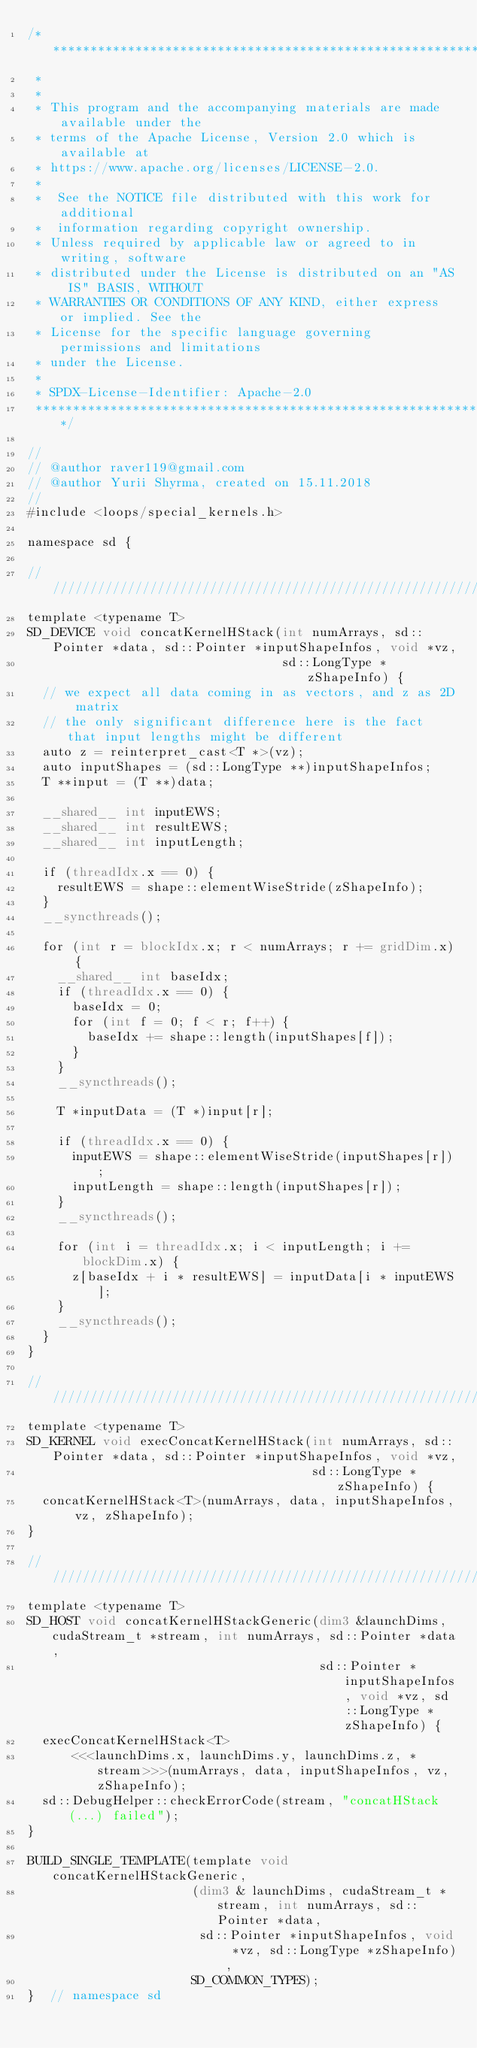<code> <loc_0><loc_0><loc_500><loc_500><_Cuda_>/* ******************************************************************************
 *
 *
 * This program and the accompanying materials are made available under the
 * terms of the Apache License, Version 2.0 which is available at
 * https://www.apache.org/licenses/LICENSE-2.0.
 *
 *  See the NOTICE file distributed with this work for additional
 *  information regarding copyright ownership.
 * Unless required by applicable law or agreed to in writing, software
 * distributed under the License is distributed on an "AS IS" BASIS, WITHOUT
 * WARRANTIES OR CONDITIONS OF ANY KIND, either express or implied. See the
 * License for the specific language governing permissions and limitations
 * under the License.
 *
 * SPDX-License-Identifier: Apache-2.0
 ******************************************************************************/

//
// @author raver119@gmail.com
// @author Yurii Shyrma, created on 15.11.2018
//
#include <loops/special_kernels.h>

namespace sd {

///////////////////////////////////////////////////////////////////////
template <typename T>
SD_DEVICE void concatKernelHStack(int numArrays, sd::Pointer *data, sd::Pointer *inputShapeInfos, void *vz,
                                  sd::LongType *zShapeInfo) {
  // we expect all data coming in as vectors, and z as 2D matrix
  // the only significant difference here is the fact that input lengths might be different
  auto z = reinterpret_cast<T *>(vz);
  auto inputShapes = (sd::LongType **)inputShapeInfos;
  T **input = (T **)data;

  __shared__ int inputEWS;
  __shared__ int resultEWS;
  __shared__ int inputLength;

  if (threadIdx.x == 0) {
    resultEWS = shape::elementWiseStride(zShapeInfo);
  }
  __syncthreads();

  for (int r = blockIdx.x; r < numArrays; r += gridDim.x) {
    __shared__ int baseIdx;
    if (threadIdx.x == 0) {
      baseIdx = 0;
      for (int f = 0; f < r; f++) {
        baseIdx += shape::length(inputShapes[f]);
      }
    }
    __syncthreads();

    T *inputData = (T *)input[r];

    if (threadIdx.x == 0) {
      inputEWS = shape::elementWiseStride(inputShapes[r]);
      inputLength = shape::length(inputShapes[r]);
    }
    __syncthreads();

    for (int i = threadIdx.x; i < inputLength; i += blockDim.x) {
      z[baseIdx + i * resultEWS] = inputData[i * inputEWS];
    }
    __syncthreads();
  }
}

///////////////////////////////////////////////////////////////////////
template <typename T>
SD_KERNEL void execConcatKernelHStack(int numArrays, sd::Pointer *data, sd::Pointer *inputShapeInfos, void *vz,
                                      sd::LongType *zShapeInfo) {
  concatKernelHStack<T>(numArrays, data, inputShapeInfos, vz, zShapeInfo);
}

///////////////////////////////////////////////////////////////////////
template <typename T>
SD_HOST void concatKernelHStackGeneric(dim3 &launchDims, cudaStream_t *stream, int numArrays, sd::Pointer *data,
                                       sd::Pointer *inputShapeInfos, void *vz, sd::LongType *zShapeInfo) {
  execConcatKernelHStack<T>
      <<<launchDims.x, launchDims.y, launchDims.z, *stream>>>(numArrays, data, inputShapeInfos, vz, zShapeInfo);
  sd::DebugHelper::checkErrorCode(stream, "concatHStack(...) failed");
}

BUILD_SINGLE_TEMPLATE(template void concatKernelHStackGeneric,
                      (dim3 & launchDims, cudaStream_t *stream, int numArrays, sd::Pointer *data,
                       sd::Pointer *inputShapeInfos, void *vz, sd::LongType *zShapeInfo),
                      SD_COMMON_TYPES);
}  // namespace sd
</code> 